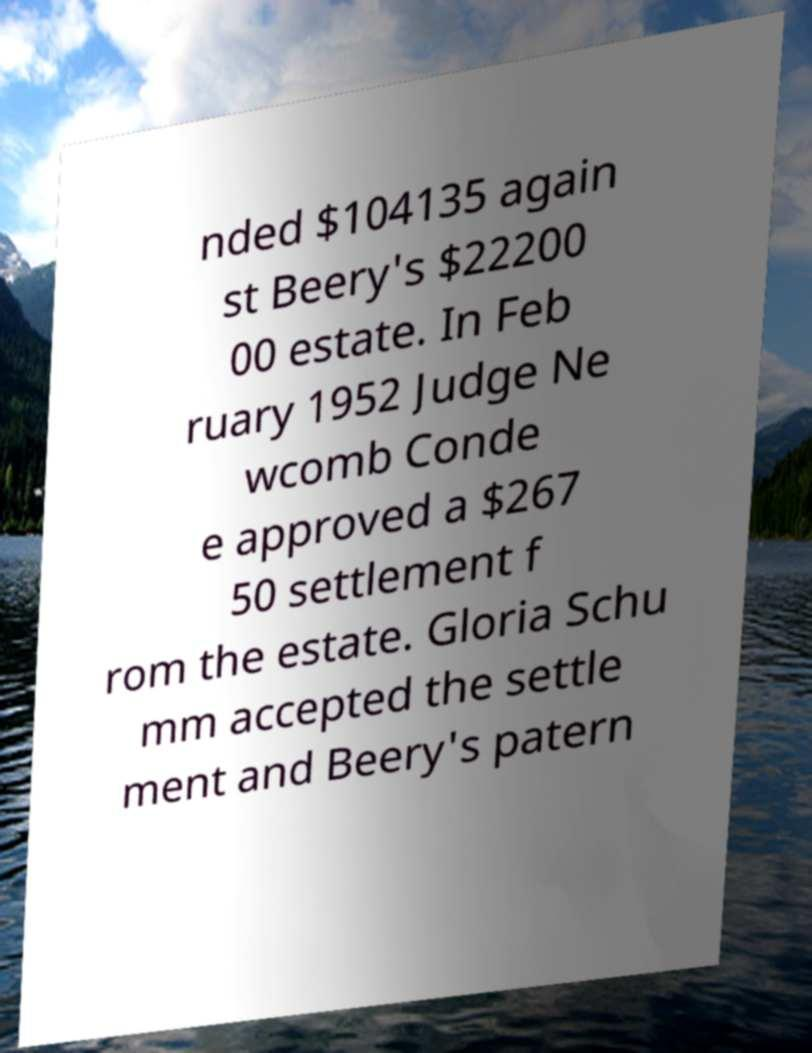Please read and relay the text visible in this image. What does it say? nded $104135 again st Beery's $22200 00 estate. In Feb ruary 1952 Judge Ne wcomb Conde e approved a $267 50 settlement f rom the estate. Gloria Schu mm accepted the settle ment and Beery's patern 